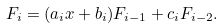<formula> <loc_0><loc_0><loc_500><loc_500>F _ { i } = ( a _ { i } x + b _ { i } ) F _ { i - 1 } + c _ { i } F _ { i - 2 } .</formula> 